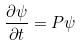<formula> <loc_0><loc_0><loc_500><loc_500>\frac { \partial \psi } { \partial t } = P \psi</formula> 